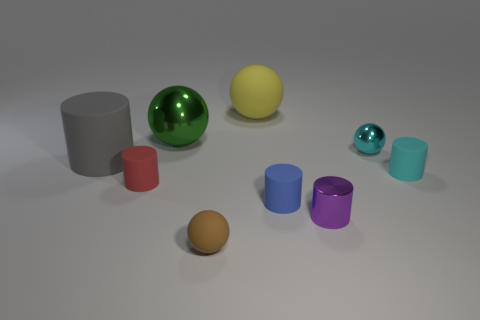Subtract all cyan cylinders. How many cylinders are left? 4 Subtract all gray cylinders. How many cylinders are left? 4 Subtract 1 cylinders. How many cylinders are left? 4 Subtract all green cylinders. Subtract all red cubes. How many cylinders are left? 5 Add 1 cyan cylinders. How many objects exist? 10 Subtract all spheres. How many objects are left? 5 Add 7 blue rubber cylinders. How many blue rubber cylinders are left? 8 Add 6 metallic cubes. How many metallic cubes exist? 6 Subtract 1 brown spheres. How many objects are left? 8 Subtract all metallic spheres. Subtract all cyan shiny objects. How many objects are left? 6 